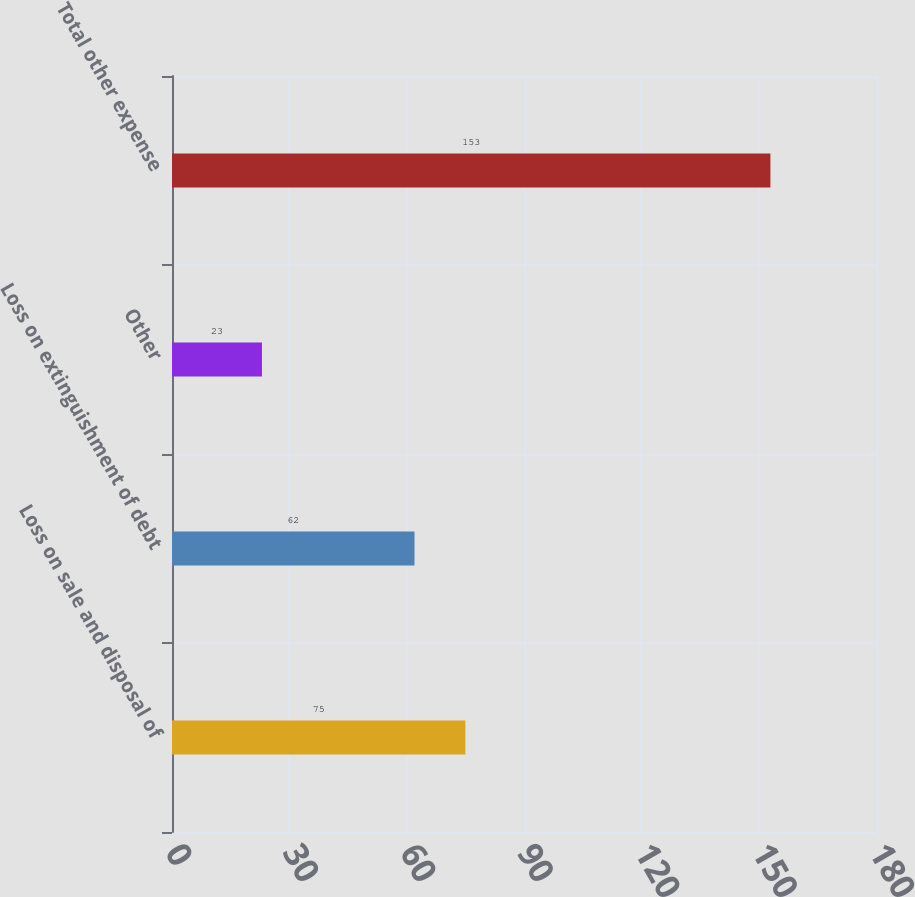<chart> <loc_0><loc_0><loc_500><loc_500><bar_chart><fcel>Loss on sale and disposal of<fcel>Loss on extinguishment of debt<fcel>Other<fcel>Total other expense<nl><fcel>75<fcel>62<fcel>23<fcel>153<nl></chart> 